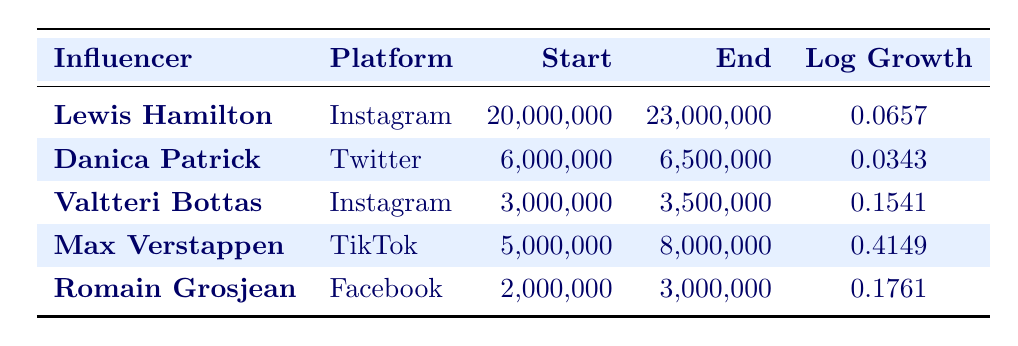What is the log growth value for Lewis Hamilton? The log growth value for Lewis Hamilton is listed in the Growth Log column of the table as 0.0657.
Answer: 0.0657 Which influencer had the highest log growth on their social media platform? Max Verstappen has the highest log growth value of 0.4149 in the table, as it is higher than other influencers listed.
Answer: Max Verstappen What is the total follower increase for Romain Grosjean? Romain Grosjean started with 2,000,000 followers and ended with 3,000,000 followers. The increase is calculated as 3,000,000 - 2,000,000 = 1,000,000.
Answer: 1,000,000 Is it true that Danica Patrick gained more than Lewis Hamilton in followers? Lewis Hamilton gained 3,000,000 followers (from 20,000,000 to 23,000,000), whereas Danica Patrick gained only 500,000 followers (from 6,000,000 to 6,500,000), confirming that Danica Patrick did not gain more.
Answer: No What is the average log growth among all influencers listed? The log growth values are 0.0657, 0.0343, 0.1541, 0.4149, and 0.1761. Summing these gives 0.8451. Dividing by the number of influencers (5) gives an average log growth of 0.8451 / 5 = 0.1690.
Answer: 0.1690 How many followers did Max Verstappen have at the start of the year? Max Verstappen had 5,000,000 followers at the start of the year, as indicated in the Start column of the table.
Answer: 5,000,000 Which social media platform did Valtteri Bottas use? The table indicates that Valtteri Bottas used Instagram, as specified in the Platform column corresponding to his name.
Answer: Instagram What is the difference in log growth between Romain Grosjean and Valtteri Bottas? Romain Grosjean's log growth is 0.1761, while Valtteri Bottas's log growth is 0.1541. The difference is calculated as 0.1761 - 0.1541 = 0.0220.
Answer: 0.0220 